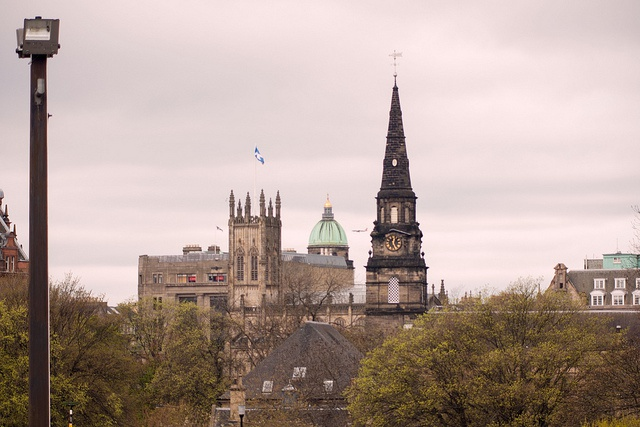Describe the objects in this image and their specific colors. I can see clock in lightgray, brown, gray, tan, and black tones, kite in lightgray, darkgray, and gray tones, and airplane in lightgray, lightpink, and pink tones in this image. 